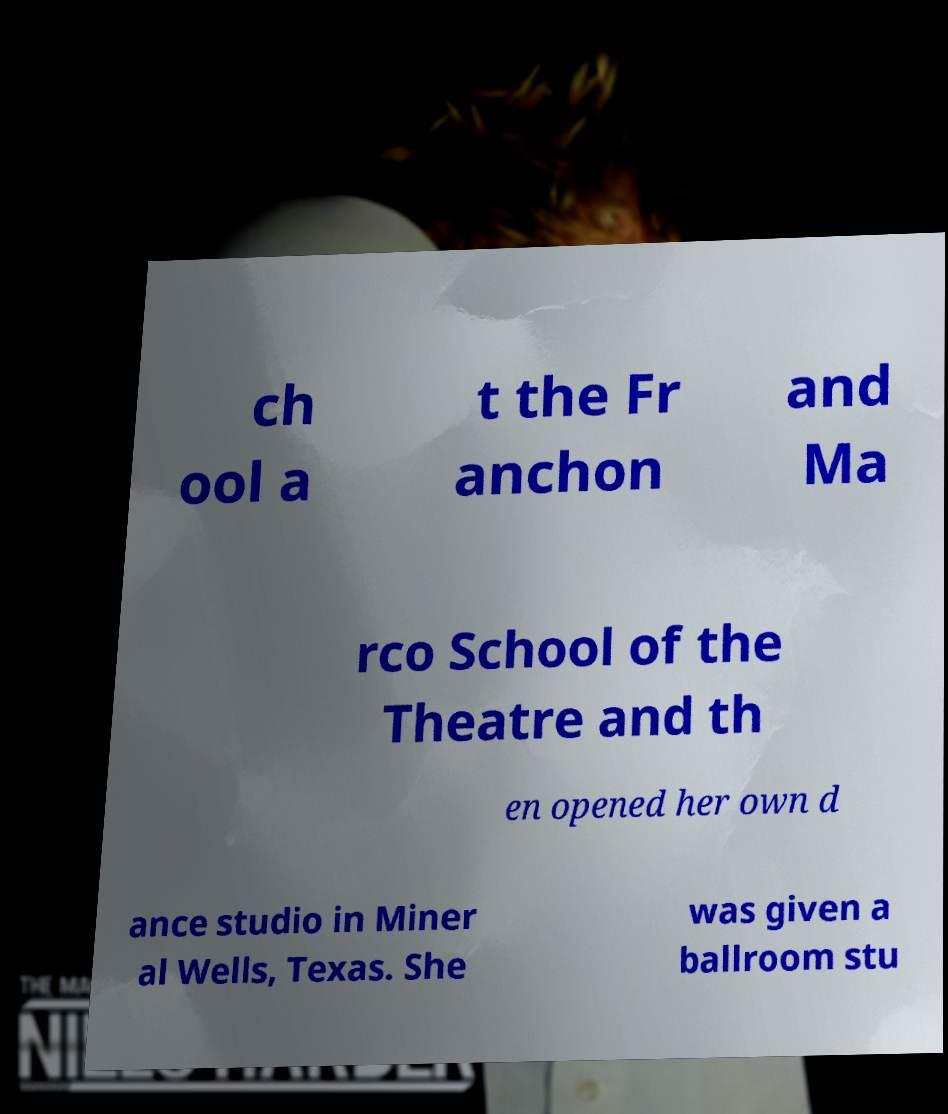Please identify and transcribe the text found in this image. ch ool a t the Fr anchon and Ma rco School of the Theatre and th en opened her own d ance studio in Miner al Wells, Texas. She was given a ballroom stu 